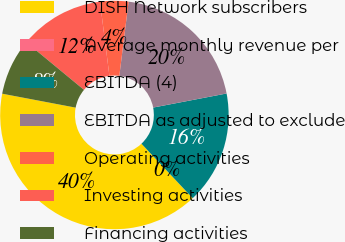Convert chart. <chart><loc_0><loc_0><loc_500><loc_500><pie_chart><fcel>DISH Network subscribers<fcel>Average monthly revenue per<fcel>EBITDA (4)<fcel>EBITDA as adjusted to exclude<fcel>Operating activities<fcel>Investing activities<fcel>Financing activities<nl><fcel>40.0%<fcel>0.0%<fcel>16.0%<fcel>20.0%<fcel>4.0%<fcel>12.0%<fcel>8.0%<nl></chart> 